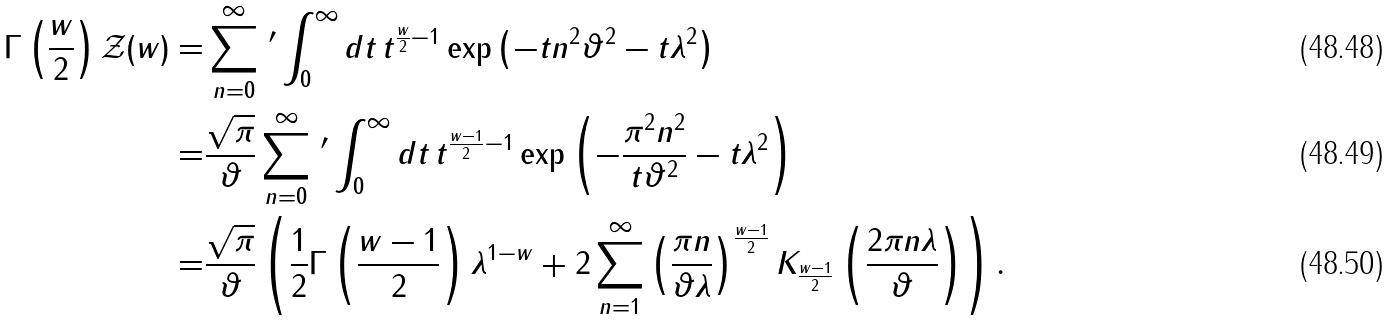Convert formula to latex. <formula><loc_0><loc_0><loc_500><loc_500>\Gamma \left ( \frac { w } { 2 } \right ) \mathcal { Z } ( w ) = & \sum _ { n = 0 } ^ { \infty } \, ^ { \prime } \int _ { 0 } ^ { \infty } d t \, t ^ { \frac { w } { 2 } - 1 } \exp \left ( - t n ^ { 2 } \vartheta ^ { 2 } - t \lambda ^ { 2 } \right ) \\ = & \frac { \sqrt { \pi } } { \vartheta } \sum _ { n = 0 } ^ { \infty } \, ^ { \prime } \int _ { 0 } ^ { \infty } d t \, t ^ { \frac { w - 1 } { 2 } - 1 } \exp \left ( - \frac { \pi ^ { 2 } n ^ { 2 } } { t \vartheta ^ { 2 } } - t \lambda ^ { 2 } \right ) \\ = & \frac { \sqrt { \pi } } { \vartheta } \left ( \frac { 1 } { 2 } \Gamma \left ( \frac { w - 1 } { 2 } \right ) \lambda ^ { 1 - w } + 2 \sum _ { n = 1 } ^ { \infty } \left ( \frac { \pi n } { \vartheta \lambda } \right ) ^ { \frac { w - 1 } { 2 } } K _ { \frac { w - 1 } { 2 } } \left ( \frac { 2 \pi n \lambda } { \vartheta } \right ) \right ) .</formula> 